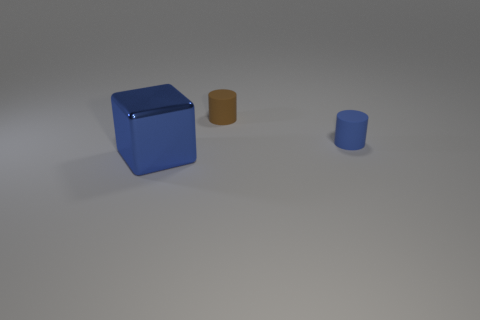Add 3 brown matte cylinders. How many objects exist? 6 Subtract all blocks. How many objects are left? 2 Subtract 1 blue cubes. How many objects are left? 2 Subtract all large blue things. Subtract all tiny blue matte cylinders. How many objects are left? 1 Add 2 blue shiny cubes. How many blue shiny cubes are left? 3 Add 1 large blue metallic objects. How many large blue metallic objects exist? 2 